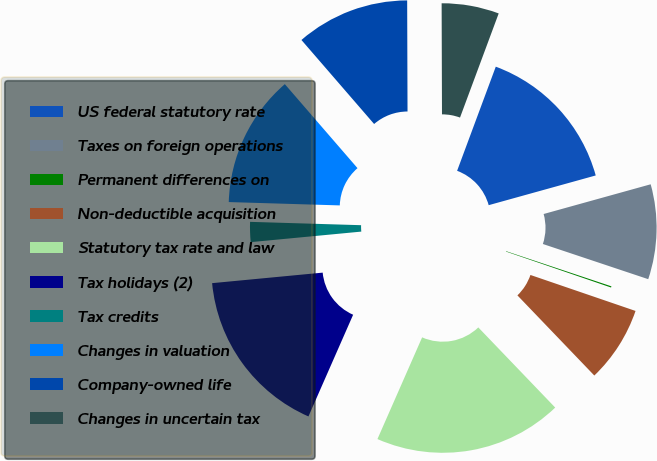<chart> <loc_0><loc_0><loc_500><loc_500><pie_chart><fcel>US federal statutory rate<fcel>Taxes on foreign operations<fcel>Permanent differences on<fcel>Non-deductible acquisition<fcel>Statutory tax rate and law<fcel>Tax holidays (2)<fcel>Tax credits<fcel>Changes in valuation<fcel>Company-owned life<fcel>Changes in uncertain tax<nl><fcel>15.03%<fcel>9.44%<fcel>0.12%<fcel>7.58%<fcel>18.76%<fcel>16.9%<fcel>1.99%<fcel>13.17%<fcel>11.3%<fcel>5.71%<nl></chart> 